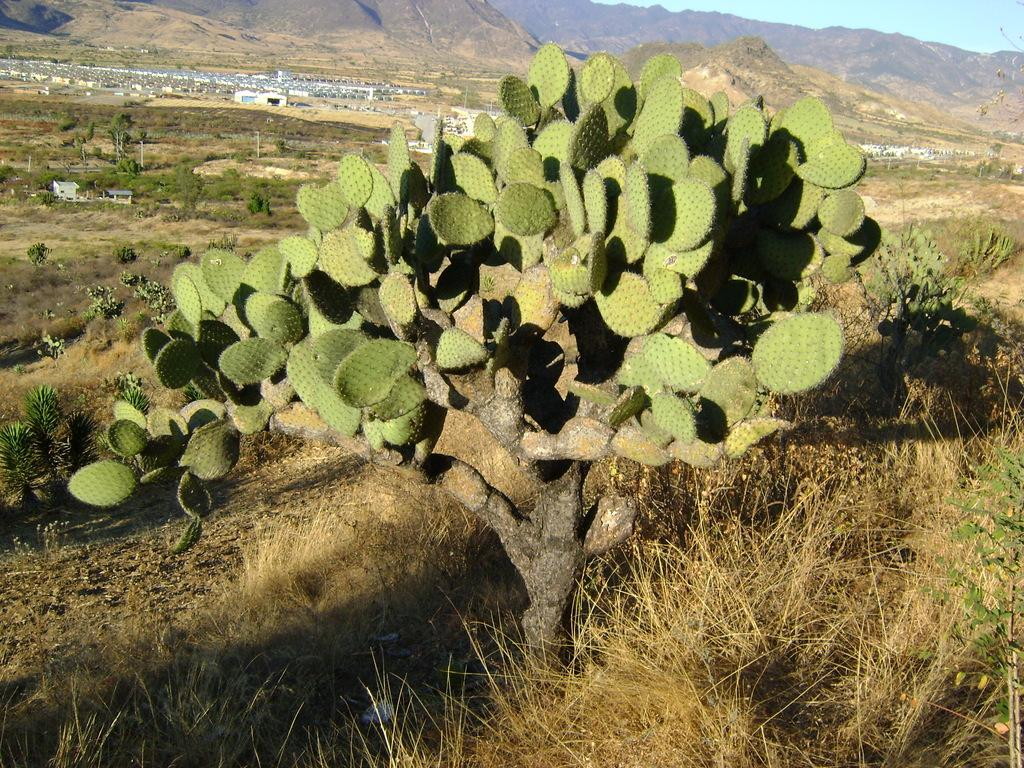What type of plant can be seen in the image? There is a cactus tree in the image. What type of vegetation is present besides the cactus tree? There is grass, plants, and trees in the image. What type of structures are visible in the image? There are buildings in the image. What type of natural feature can be seen in the image? There are hills in the image. What is visible in the background of the image? The sky is visible in the background of the image. What type of coach can be seen driving through the hills in the image? There is no coach present in the image; it features a cactus tree, grass, plants, trees, buildings, hills, and the sky. What type of arithmetic problem can be solved using the number of trees in the image? There is no arithmetic problem related to the number of trees in the image, as the focus is on describing the image's contents. 